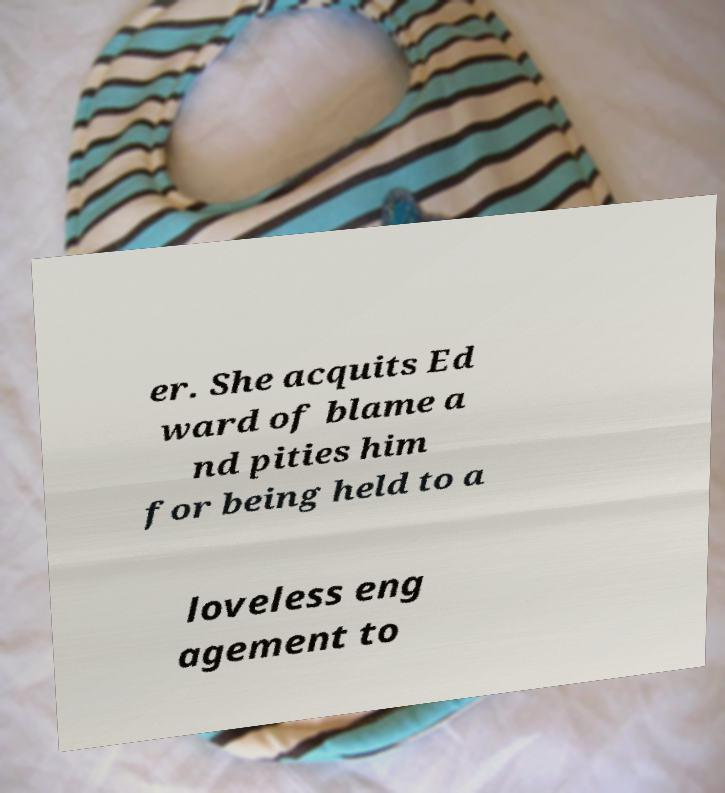Please read and relay the text visible in this image. What does it say? er. She acquits Ed ward of blame a nd pities him for being held to a loveless eng agement to 